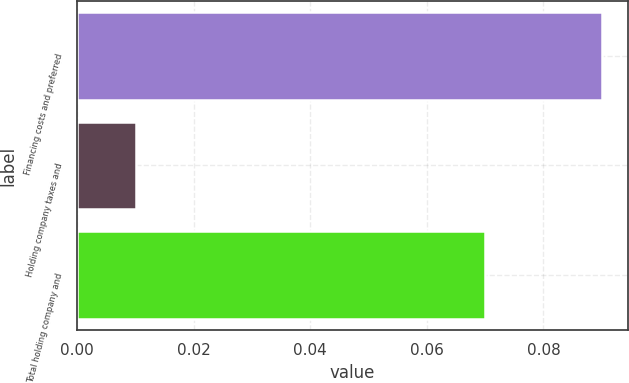<chart> <loc_0><loc_0><loc_500><loc_500><bar_chart><fcel>Financing costs and preferred<fcel>Holding company taxes and<fcel>Total holding company and<nl><fcel>0.09<fcel>0.01<fcel>0.07<nl></chart> 